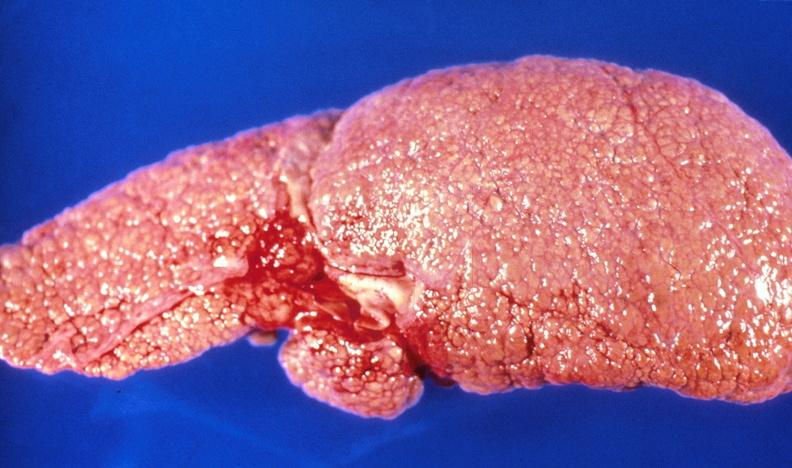what does this image show?
Answer the question using a single word or phrase. Alcoholic cirrhosis 